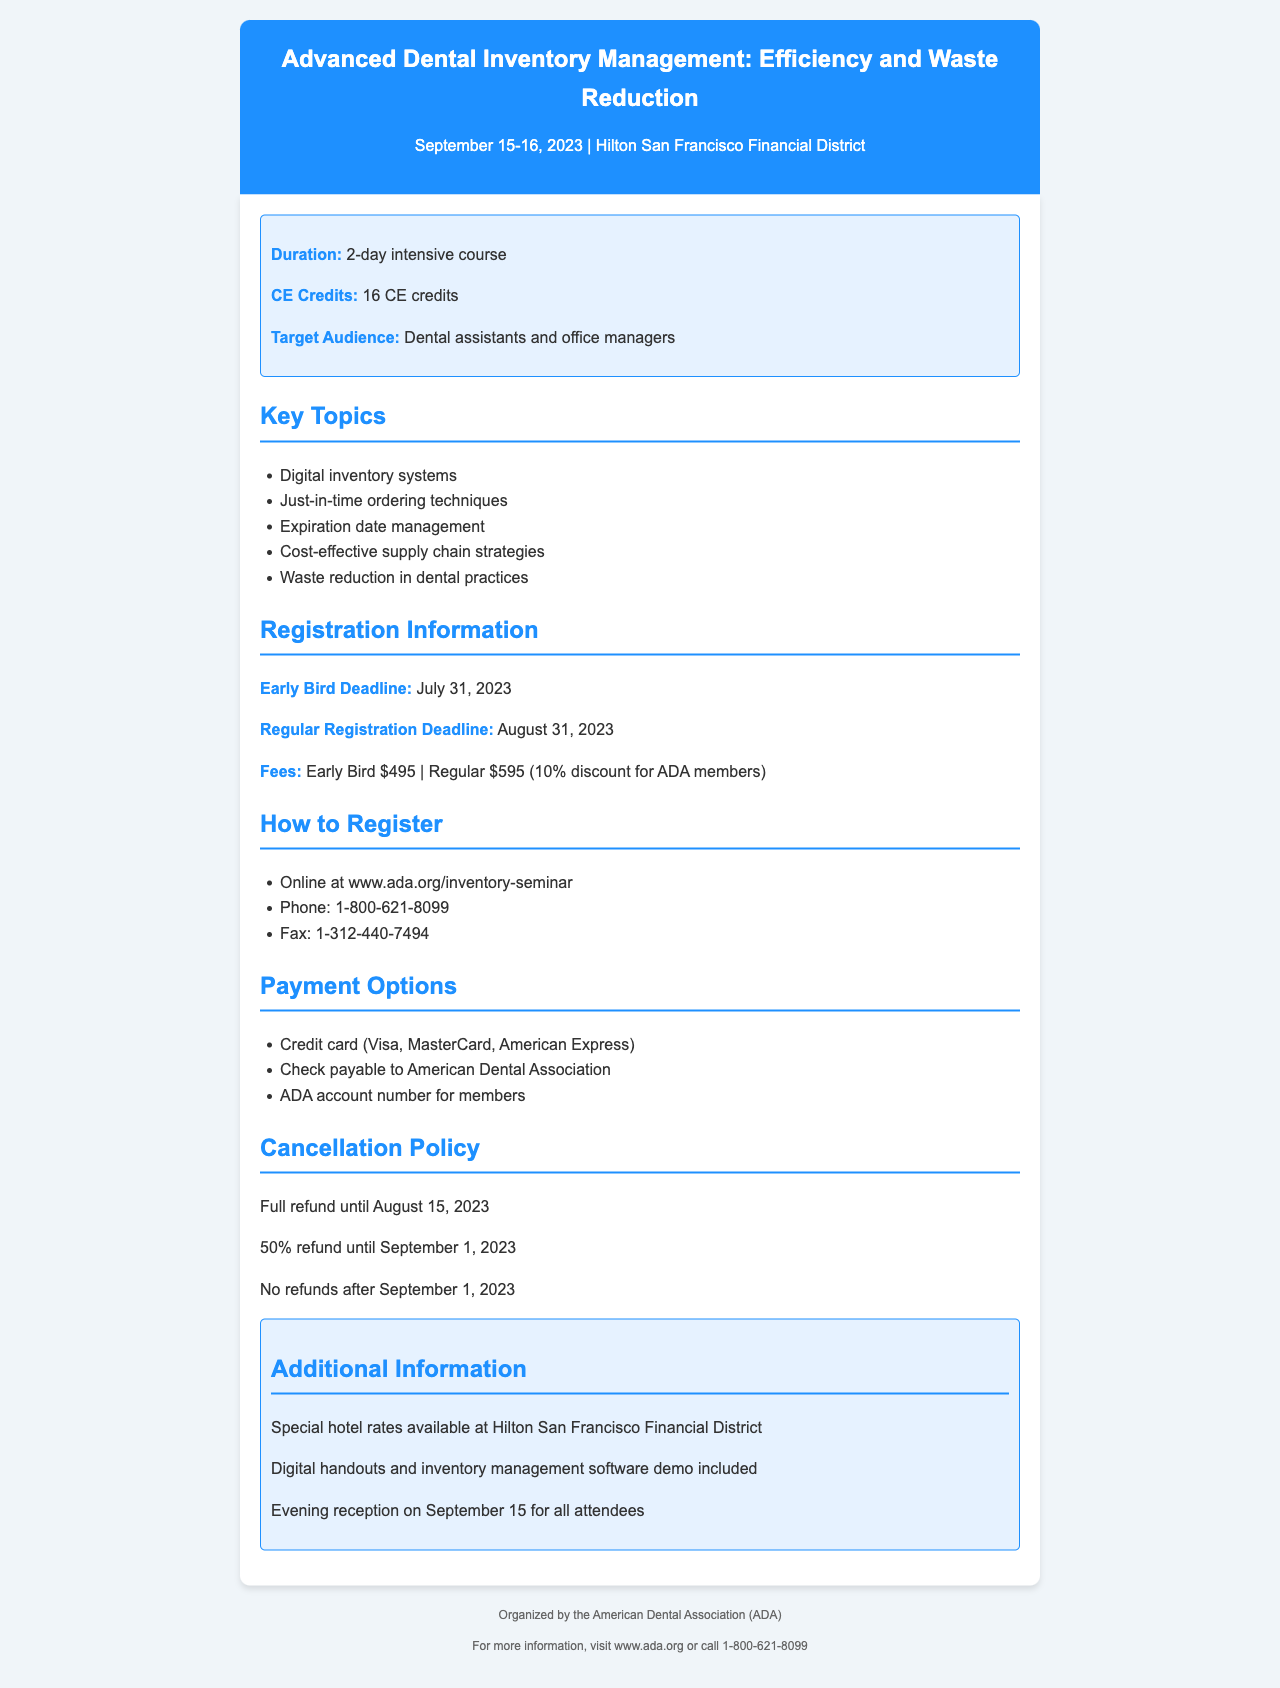What are the dates of the seminar? The seminar is scheduled for September 15-16, 2023.
Answer: September 15-16, 2023 What is the total number of CE credits offered? The document states that the course provides 16 CE credits.
Answer: 16 CE credits What is the early bird registration fee? The early bird registration fee is mentioned as $495.
Answer: $495 Who is the target audience for the seminar? The seminar is targeted specifically at dental assistants and office managers.
Answer: Dental assistants and office managers What is the cancellation policy regarding refunds? The cancellation policy details that there is a full refund until August 15, 2023.
Answer: Full refund until August 15, 2023 What are the accepted payment methods? The document lists credit card options, check, and ADA account number for payment.
Answer: Credit card, check, ADA account number How many days is the seminar? The seminar lasts for a duration of 2 days.
Answer: 2-day What is the venue of the seminar? The seminar will be held at the Hilton San Francisco Financial District.
Answer: Hilton San Francisco Financial District When is the regular registration deadline? The regular registration deadline is August 31, 2023.
Answer: August 31, 2023 